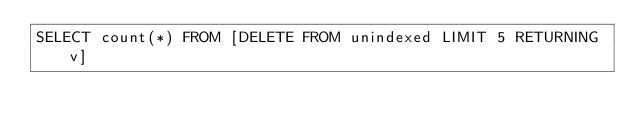<code> <loc_0><loc_0><loc_500><loc_500><_SQL_>SELECT count(*) FROM [DELETE FROM unindexed LIMIT 5 RETURNING v]
</code> 